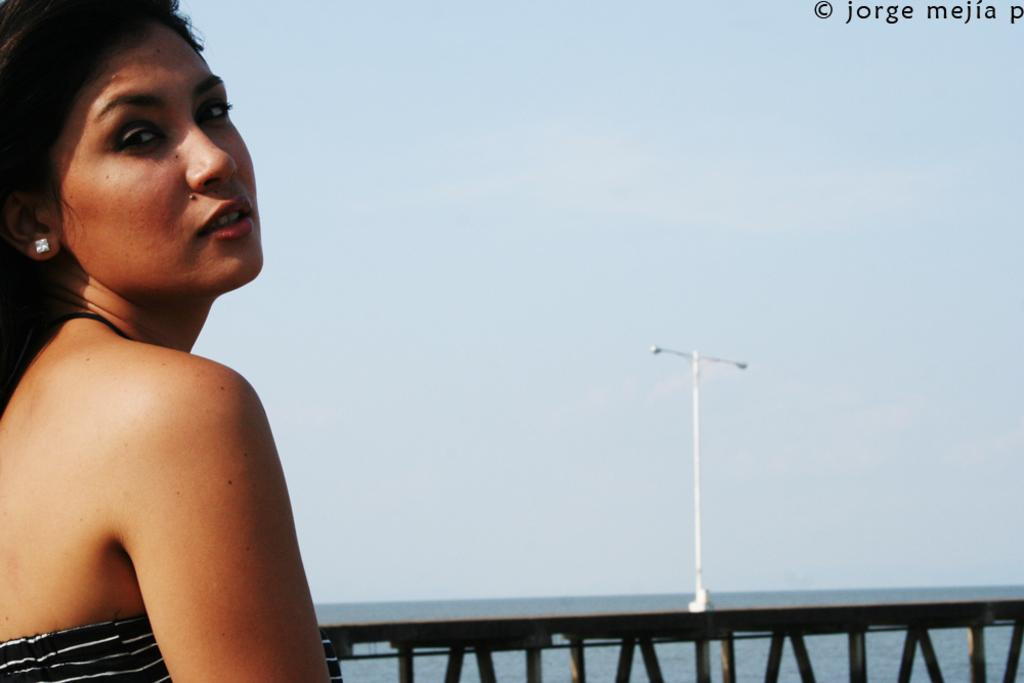Who is the main subject in the foreground of the picture? There is a woman in the foreground of the picture. What can be seen in the background of the picture? There is a railing, a pole, the sky, and water visible in the background of the picture. What time is displayed on the clock in the picture? There is no clock present in the image. How much payment is required for the services provided in the picture? There is no indication of any payment or services in the image. 